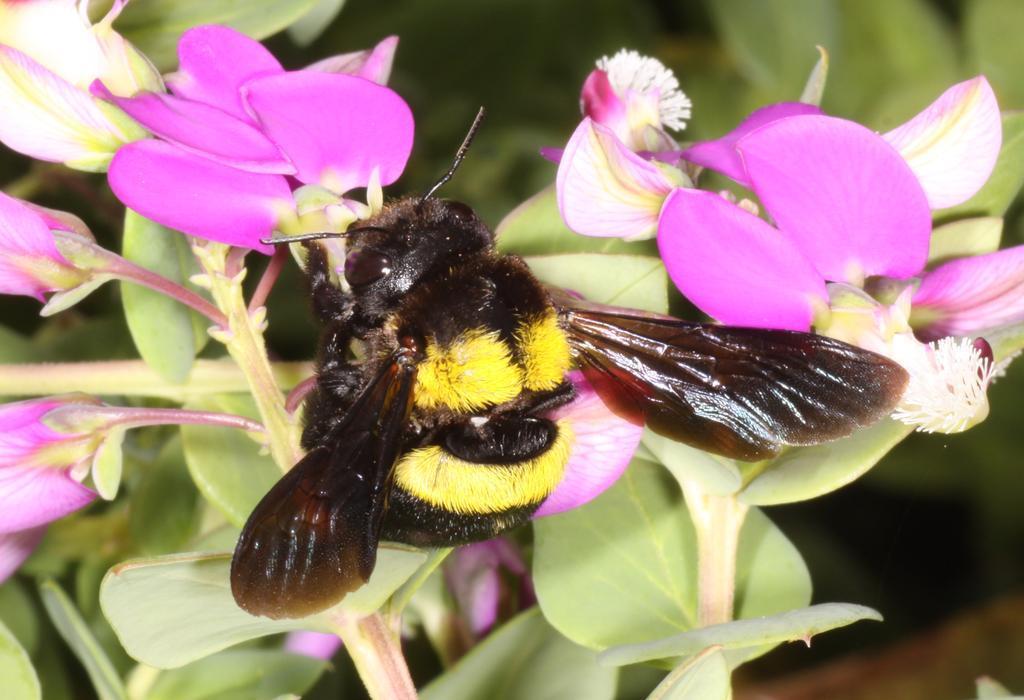Could you give a brief overview of what you see in this image? In this image there is a bee on the flower, there are leaves of a plant. The background is blurry. 